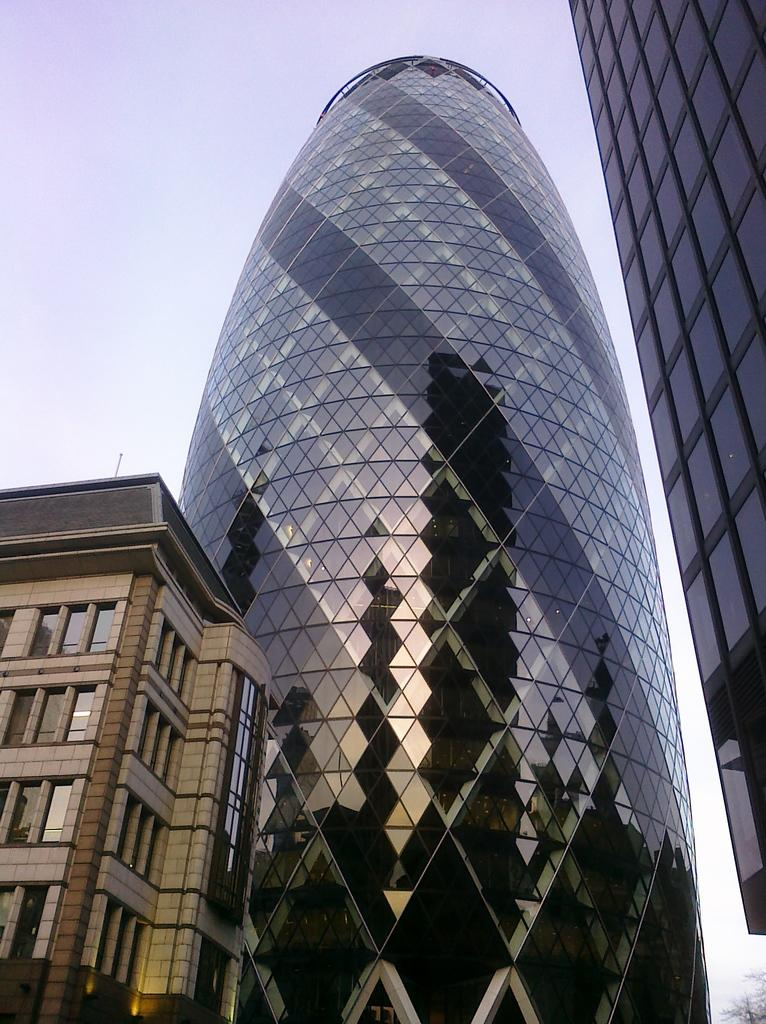What type of structure is located in the bottom left corner of the image? There is a building in the bottom left corner of the image. What can be seen in the middle of the image? There are glass buildings in the middle of the image. What is visible at the top of the image? The sky is visible at the top of the image. Can you tell me where the queen is sitting in the image? There is no queen present in the image. What type of material is the stone made of in the image? There is no stone present in the image. 